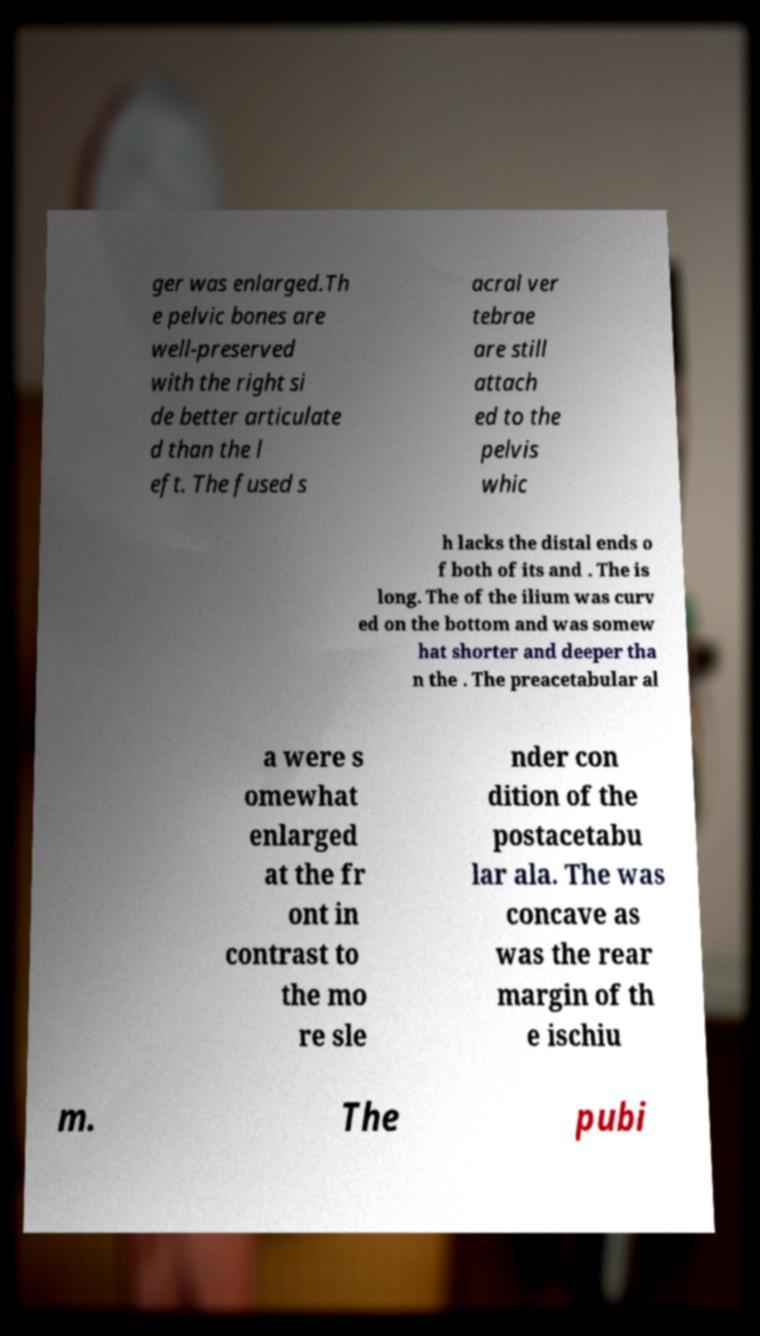Can you read and provide the text displayed in the image?This photo seems to have some interesting text. Can you extract and type it out for me? ger was enlarged.Th e pelvic bones are well-preserved with the right si de better articulate d than the l eft. The fused s acral ver tebrae are still attach ed to the pelvis whic h lacks the distal ends o f both of its and . The is long. The of the ilium was curv ed on the bottom and was somew hat shorter and deeper tha n the . The preacetabular al a were s omewhat enlarged at the fr ont in contrast to the mo re sle nder con dition of the postacetabu lar ala. The was concave as was the rear margin of th e ischiu m. The pubi 